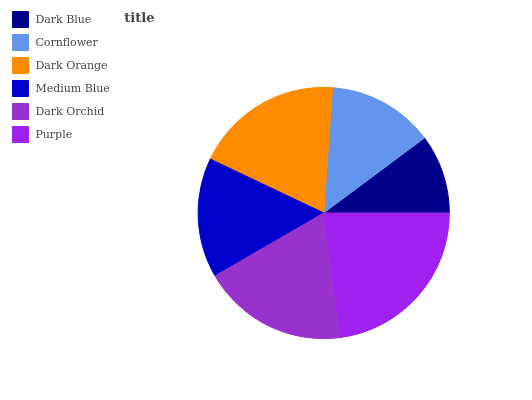Is Dark Blue the minimum?
Answer yes or no. Yes. Is Purple the maximum?
Answer yes or no. Yes. Is Cornflower the minimum?
Answer yes or no. No. Is Cornflower the maximum?
Answer yes or no. No. Is Cornflower greater than Dark Blue?
Answer yes or no. Yes. Is Dark Blue less than Cornflower?
Answer yes or no. Yes. Is Dark Blue greater than Cornflower?
Answer yes or no. No. Is Cornflower less than Dark Blue?
Answer yes or no. No. Is Dark Orchid the high median?
Answer yes or no. Yes. Is Medium Blue the low median?
Answer yes or no. Yes. Is Dark Orange the high median?
Answer yes or no. No. Is Purple the low median?
Answer yes or no. No. 